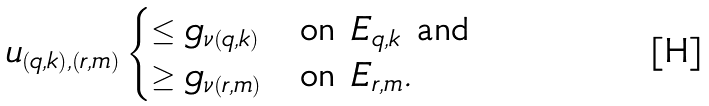<formula> <loc_0><loc_0><loc_500><loc_500>u _ { ( q , k ) , ( r , m ) } \begin{cases} \leq g _ { \nu ( q , k ) } & \text {on } E _ { q , k } \text { and} \\ \geq g _ { \nu ( r , m ) } & \text {on } E _ { r , m } . \end{cases}</formula> 